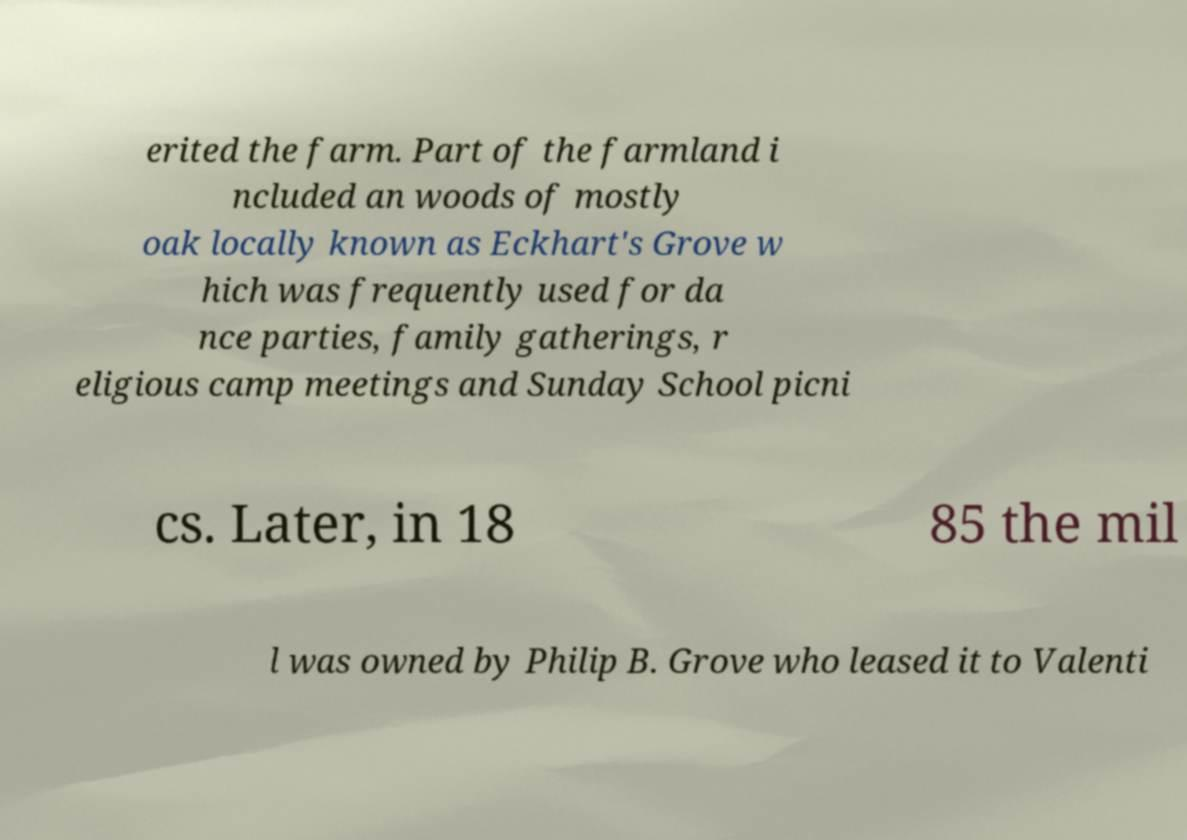Can you accurately transcribe the text from the provided image for me? erited the farm. Part of the farmland i ncluded an woods of mostly oak locally known as Eckhart's Grove w hich was frequently used for da nce parties, family gatherings, r eligious camp meetings and Sunday School picni cs. Later, in 18 85 the mil l was owned by Philip B. Grove who leased it to Valenti 